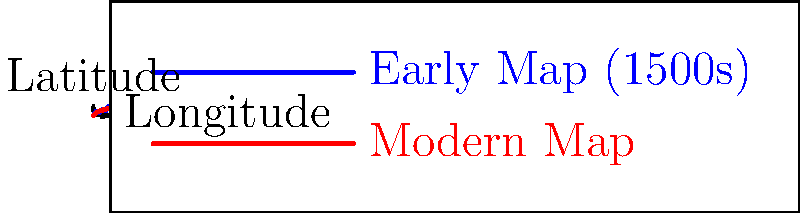Analyze the accuracy of the coastline representation in the early African map (blue line) compared to the modern map (red line). What is the most significant discrepancy between the two representations, and what factors might have contributed to this inaccuracy in early cartography? To analyze the accuracy of the coastline representation, we need to compare the early map (blue line) with the modern map (red line) step by step:

1. General trend: Both lines show an overall increasing trend from left to right, indicating a general understanding of the coastline's shape.

2. Starting point: Both lines begin at the origin (0,0), showing agreement on the initial reference point.

3. Mid-section (longitude 1-3):
   a. The early map shows more exaggerated fluctuations in latitude.
   b. The modern map presents a smoother, more gradual increase.

4. End section (longitude 3-5):
   a. The early map shows a steep increase in latitude.
   b. The modern map maintains a more gradual slope.

5. Most significant discrepancy: The largest difference is observed in the final section (longitude 3-5), where the early map greatly overestimates the latitude compared to the modern map.

Factors contributing to this inaccuracy in early cartography:

a. Limited exploration: Early cartographers had incomplete knowledge of the African coastline due to limited exploration.

b. Navigation techniques: Less advanced navigation tools and techniques led to errors in latitude and longitude measurements.

c. Mapping methods: Early maps often relied on a combination of actual observations and speculation, leading to exaggerations or simplifications.

d. Projections: Understanding of map projections was limited, causing distortions when representing a spherical Earth on a flat surface.

e. Political influences: Maps sometimes reflected political aspirations or claims, leading to intentional or unintentional distortions.

f. Cumulative errors: As maps were copied and redrawn, small errors could compound over time.

The most significant discrepancy (overestimation of latitude in the final section) likely resulted from a combination of these factors, particularly limited exploration and reliance on speculation for less-known areas.
Answer: Overestimation of latitude in the final section (longitude 3-5), due to limited exploration and reliance on speculation. 